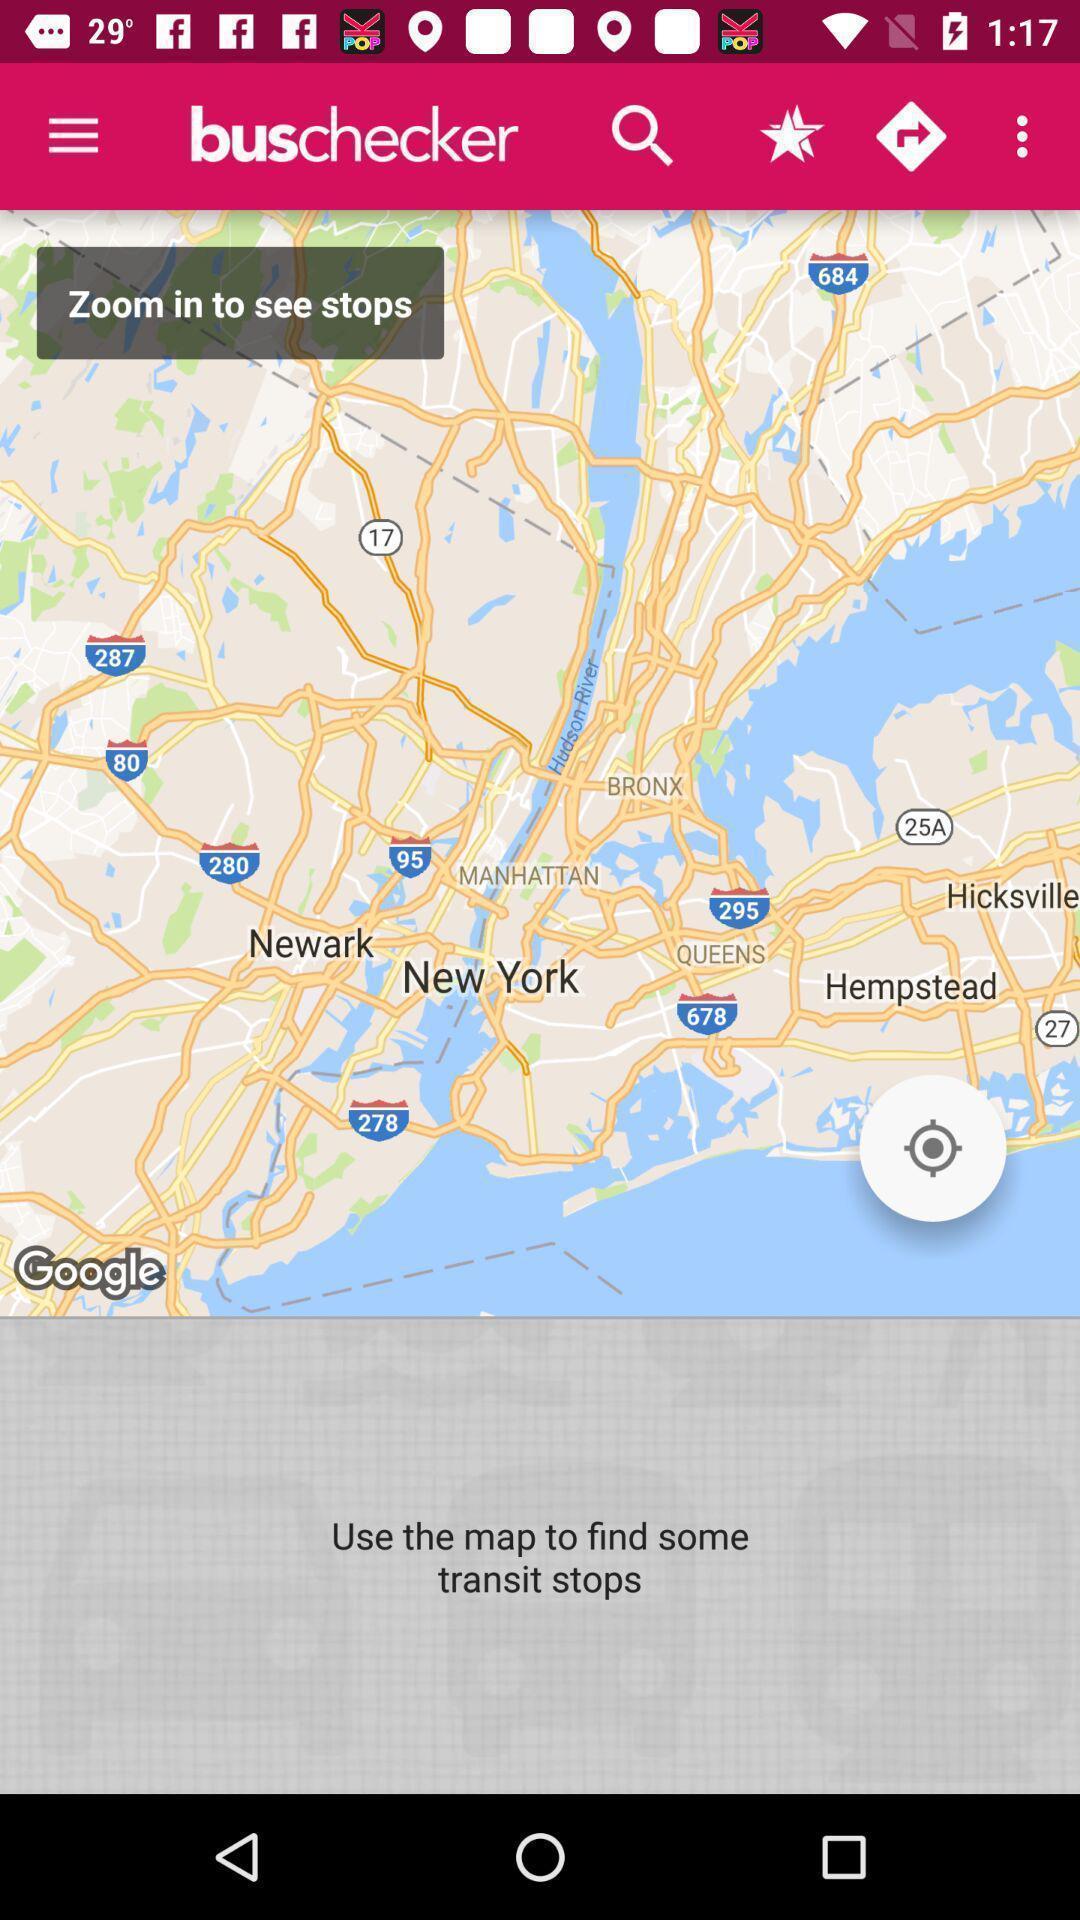Describe this image in words. Page showing different locations in map. 